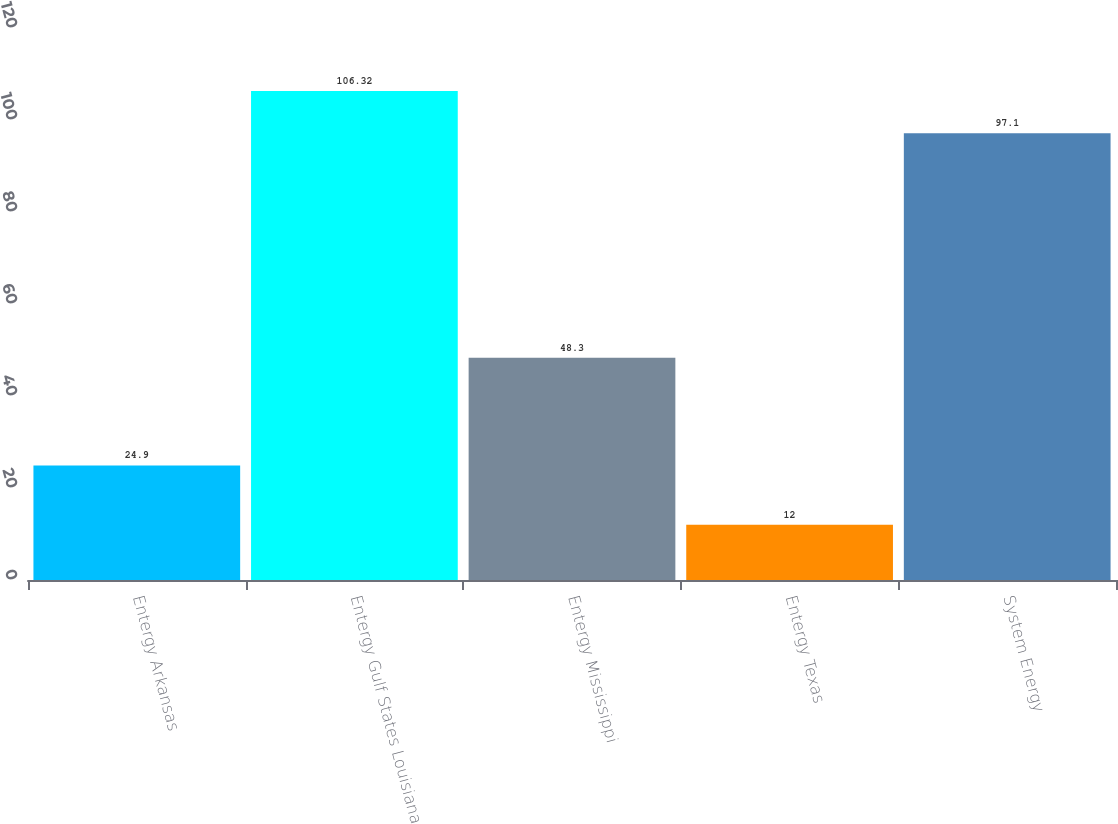Convert chart. <chart><loc_0><loc_0><loc_500><loc_500><bar_chart><fcel>Entergy Arkansas<fcel>Entergy Gulf States Louisiana<fcel>Entergy Mississippi<fcel>Entergy Texas<fcel>System Energy<nl><fcel>24.9<fcel>106.32<fcel>48.3<fcel>12<fcel>97.1<nl></chart> 